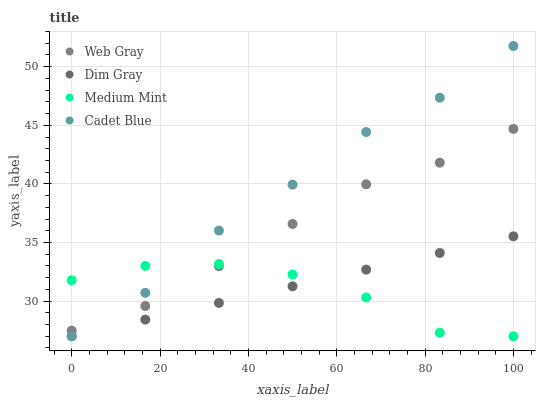Does Medium Mint have the minimum area under the curve?
Answer yes or no. Yes. Does Cadet Blue have the maximum area under the curve?
Answer yes or no. Yes. Does Dim Gray have the minimum area under the curve?
Answer yes or no. No. Does Dim Gray have the maximum area under the curve?
Answer yes or no. No. Is Dim Gray the smoothest?
Answer yes or no. Yes. Is Medium Mint the roughest?
Answer yes or no. Yes. Is Web Gray the smoothest?
Answer yes or no. No. Is Web Gray the roughest?
Answer yes or no. No. Does Medium Mint have the lowest value?
Answer yes or no. Yes. Does Web Gray have the lowest value?
Answer yes or no. No. Does Cadet Blue have the highest value?
Answer yes or no. Yes. Does Dim Gray have the highest value?
Answer yes or no. No. Is Dim Gray less than Web Gray?
Answer yes or no. Yes. Is Web Gray greater than Dim Gray?
Answer yes or no. Yes. Does Medium Mint intersect Cadet Blue?
Answer yes or no. Yes. Is Medium Mint less than Cadet Blue?
Answer yes or no. No. Is Medium Mint greater than Cadet Blue?
Answer yes or no. No. Does Dim Gray intersect Web Gray?
Answer yes or no. No. 